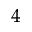Convert formula to latex. <formula><loc_0><loc_0><loc_500><loc_500>^ { 4 }</formula> 